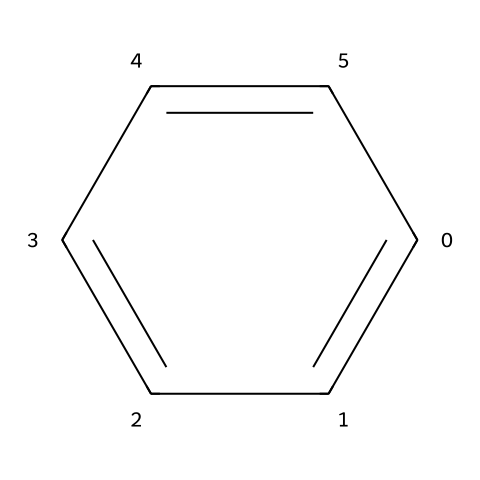What is the name of this chemical? The SMILES representation corresponds to benzene, a well-known aromatic hydrocarbon. It is identified by its unique cyclic structure and alternating double bonds.
Answer: benzene How many carbon atoms are in benzene? By examining the structure represented in the SMILES, we can count six carbon atoms forming a ring. This is characteristic of benzene's molecular arrangement.
Answer: 6 What is the number of hydrogen atoms in benzene? Each carbon atom in benzene is bonded to one hydrogen atom due to the nature of its structure, yielding a total of six hydrogen atoms in the molecule.
Answer: 6 What type of chemical bond is predominant in benzene? Benzene features alternating single and double bonds which classifies it as having aromatic character, predominant in covalent bonds due to the sharing of electron pairs.
Answer: covalent What is a health hazard associated with benzene? Benzene is classified as a carcinogen, meaning it poses significant risks for cancer development upon exposure.
Answer: carcinogen Why is benzene considered a hazardous chemical? Benzene has several associated health risks, including its toxicity, carcinogenic properties, and potential to cause harmful effects on the bone marrow, leading to blood disorders. These risks elevate its status as a hazardous substance.
Answer: toxicity 